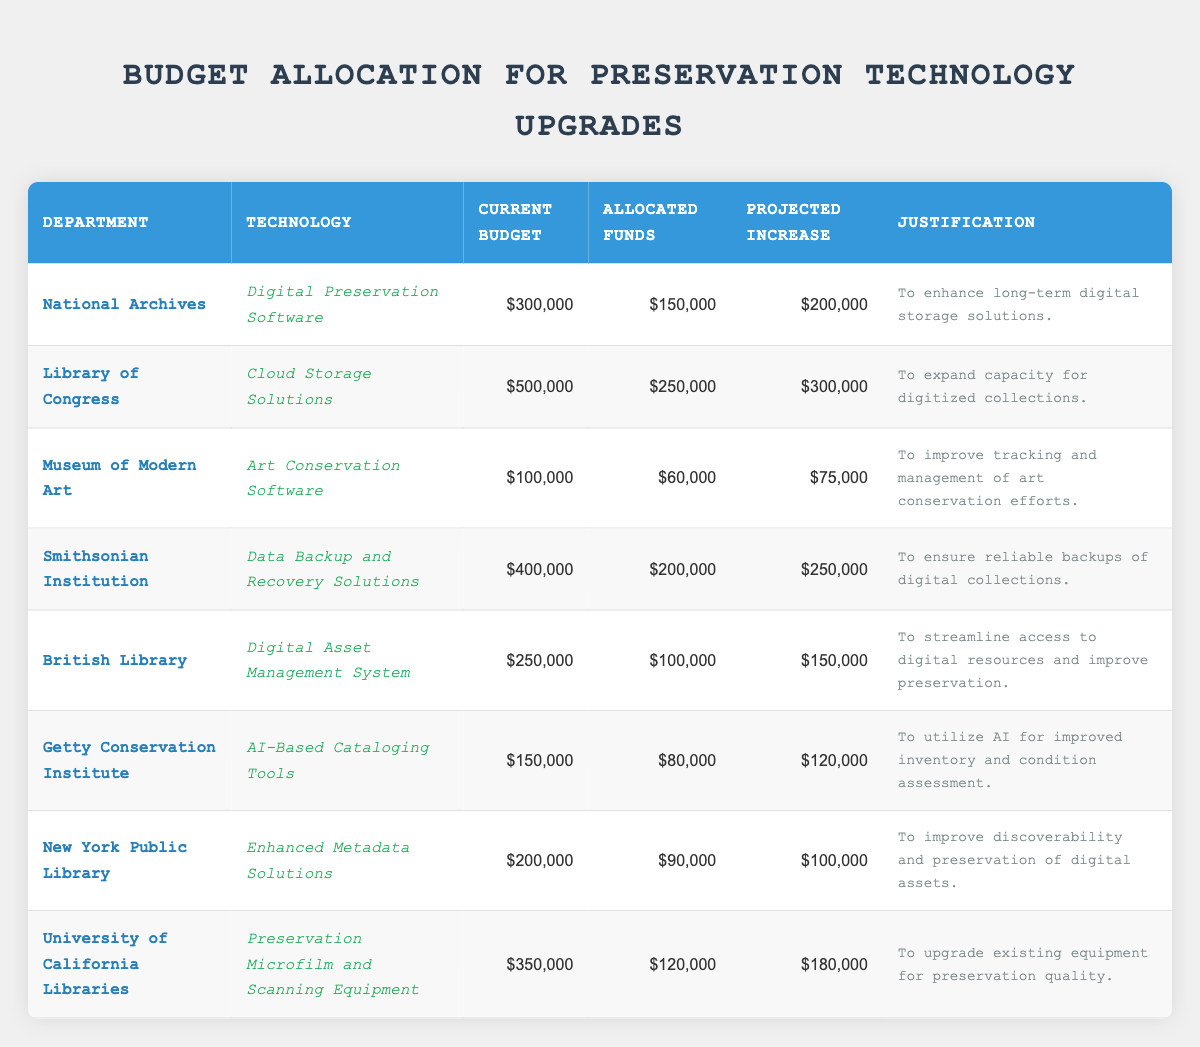What is the current budget for the Library of Congress? By referring to the table, I look at the row for the Library of Congress and find the "Current Budget" column which shows a value of $500,000.
Answer: $500,000 Which department has the highest allocated funds? I scan through the "Allocated Funds" column and identify the maximum value, which is $250,000 for the Library of Congress, making it the highest.
Answer: Library of Congress What is the total projected increase for all departments combined? I sum up all the values in the "Projected Increase" column: 200,000 + 300,000 + 75,000 + 250,000 + 150,000 + 120,000 + 100,000 + 180,000 = 1,175,000.
Answer: $1,175,000 Is the justification for the technology upgrades consistent across all departments? I examine the "Justification" column to determine if the reasons provided align or differ; they vary based on the specific needs of each department, indicating no overall consistency.
Answer: No Which department has allocated the least amount for technology upgrades? In the "Allocated Funds" column, I look for the minimum value, which is $60,000 for the Museum of Modern Art.
Answer: Museum of Modern Art What is the average current budget across all departments? I calculate the average by summing the current budgets (300,000 + 500,000 + 100,000 + 400,000 + 250,000 + 150,000 + 200,000 + 350,000 = 2,250,000) and dividing by 8 (the number of departments), resulting in 2,250,000 / 8 = 281,250.
Answer: $281,250 Does the Smithsonian Institution plan to increase its budget more than the Museum of Modern Art? I compare the "Projected Increase" values: $250,000 for the Smithsonian Institution versus $75,000 for the Museum of Modern Art, confirming it is indeed higher.
Answer: Yes What percentage of the current budget of the British Library is allocated for technology upgrades? I take the "Allocated Funds" for the British Library ($100,000) and divide it by the "Current Budget" ($250,000), multiplying by 100 gives (100,000 / 250,000) * 100 = 40%.
Answer: 40% Which technology has the lowest current budget allocation? I look at the "Current Budget" column and identify the minimum value, which corresponds to the Museum of Modern Art's "Art Conservation Software" with a budget of $100,000.
Answer: Art Conservation Software If we exclude the department with the highest budget, what is the total allocated funds for the remaining departments? First, I identify that the Library of Congress has the highest current budget of $500,000. Then, I sum the allocated funds for the other departments: 150,000 + 60,000 + 200,000 + 100,000 + 80,000 + 90,000 + 120,000 = 800,000.
Answer: $800,000 